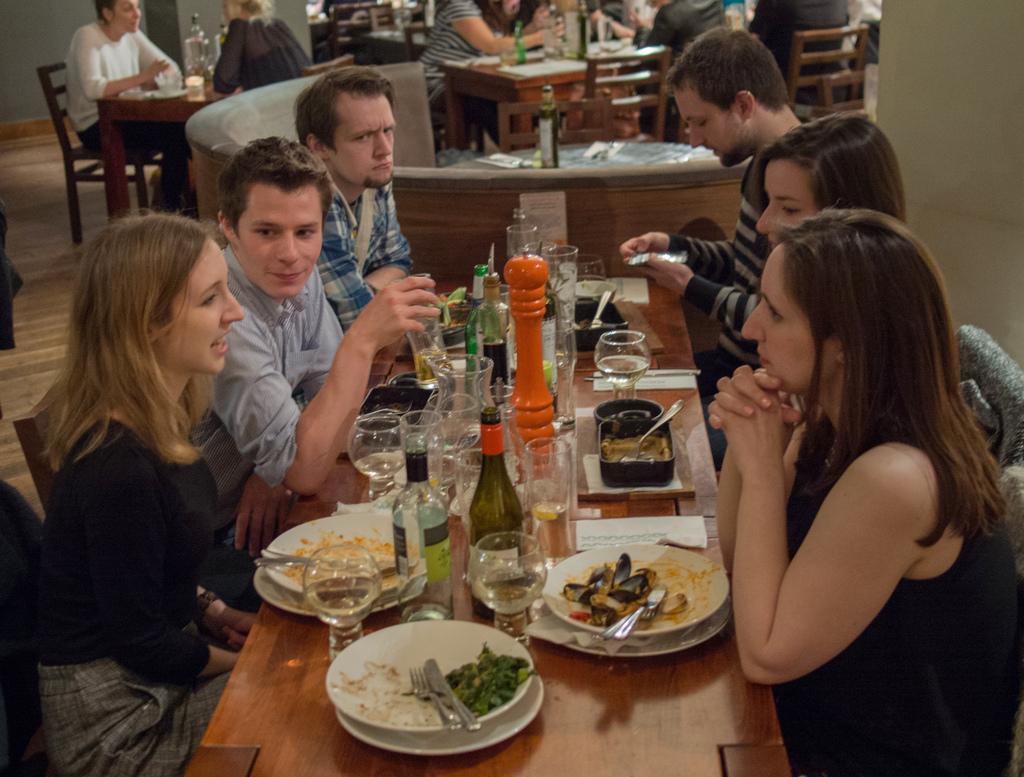In one or two sentences, can you explain what this image depicts? It is a closed room where many people are sitting on the chairs in front of the tables. On the tables there are wine bottles, glasses, plates ,spoons and dishes. 